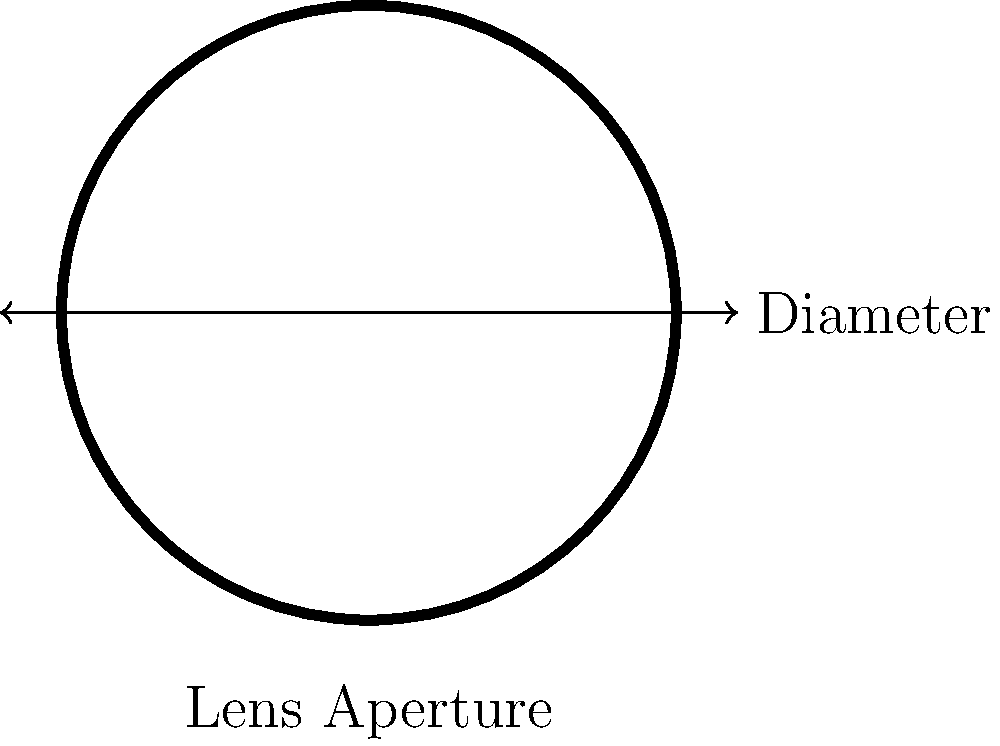As a fellow artist specializing in abstract photography, you're analyzing a circular lens aperture for a new project. The diameter of the aperture is 50mm. What is the perimeter of this circular aperture? Express your answer in millimeters and round to two decimal places. To find the perimeter of a circular lens aperture, we need to use the formula for the circumference of a circle. Let's break it down step-by-step:

1. The formula for the circumference (perimeter) of a circle is:
   $$C = \pi d$$
   where $C$ is the circumference, $\pi$ is pi, and $d$ is the diameter.

2. We're given the diameter: $d = 50$ mm

3. Substituting this into our formula:
   $$C = \pi \times 50$$

4. $\pi$ is approximately 3.14159, so:
   $$C \approx 3.14159 \times 50$$

5. Calculating this:
   $$C \approx 157.0795$$ mm

6. Rounding to two decimal places:
   $$C \approx 157.08$$ mm

Therefore, the perimeter of the circular lens aperture is approximately 157.08 mm.
Answer: 157.08 mm 